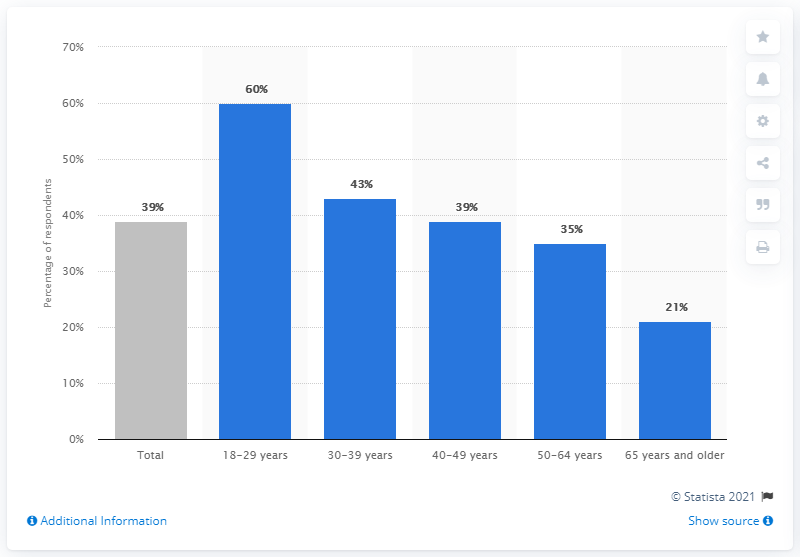Indicate a few pertinent items in this graphic. The grey color represents the total. The ratio of people aged 30 to 39 to those aged 65 and older is approximately 2.047619048. 